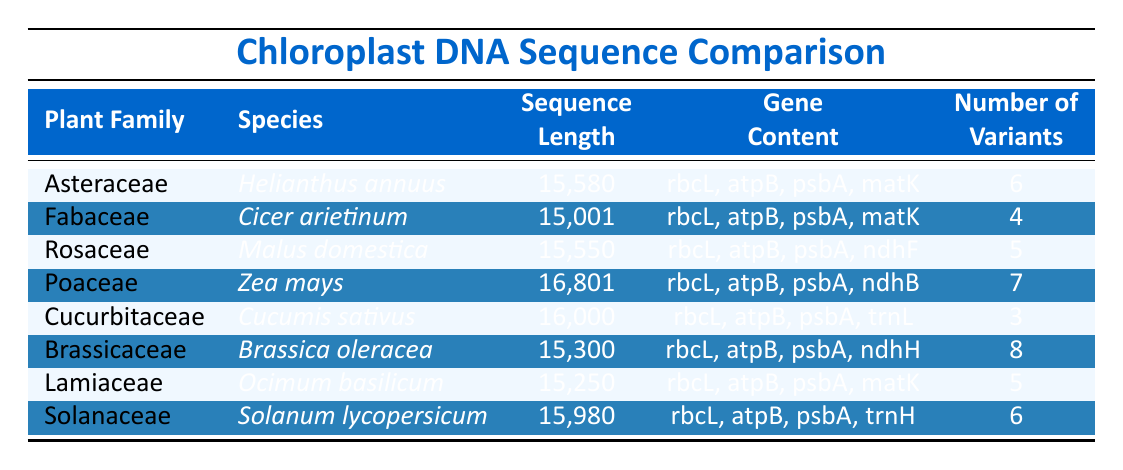What is the sequence length of Zea mays? Referring to the table, under the species Zea mays, the sequence length is listed as 16801.
Answer: 16801 Which plant family has the highest number of variants? The number of variants for each family is listed. The highest number is 8, which corresponds to the Brassicaceae family.
Answer: Brassicaceae Is the gene content for Helianthus annuus the same as that for Cicer arietinum? The gene content for Helianthus annuus is rbcL, atpB, psbA, matK; for Cicer arietinum it is the same, so the statement is true.
Answer: Yes What is the average sequence length of the plants in the Asteraceae and Rosaceae families? Sequence lengths for Asteraceae (15580) and Rosaceae (15550) can be added: 15580 + 15550 = 31130. The average, therefore, is 31130 divided by 2, which equals 15565.
Answer: 15565 Are there more gene contents listed for the Brassicaceae than for the Cucurbitaceae? Brassicaceae has rbcL, atpB, psbA, ndhH (4 gene contents) and Cucurbitaceae has rbcL, atpB, psbA, trnL (4 gene contents), so the comparison shows they are equal.
Answer: No Which species has the longest sequence length and what is that length? By examining the sequence lengths, Zea mays at 16801 is the longest compared to the others which are shorter.
Answer: 16801 How many families have a sequence length longer than 15500? The families with lengths longer than 15500 are Asteraceae (15580), Rosaceae (15550), Poaceae (16801), and Cucurbitaceae (16000), totaling four families.
Answer: 4 What is the difference in the number of variants between Cucurbitaceae and Poaceae? Cucurbitaceae has 3 variants and Poaceae has 7 variants. The difference is calculated as 7 - 3 = 4.
Answer: 4 Which plant species have a gene content that includes ndhB? The table lists Zea mays under the Poaceae family with gene content including ndhB. No other species has ndhB.
Answer: Zea mays 